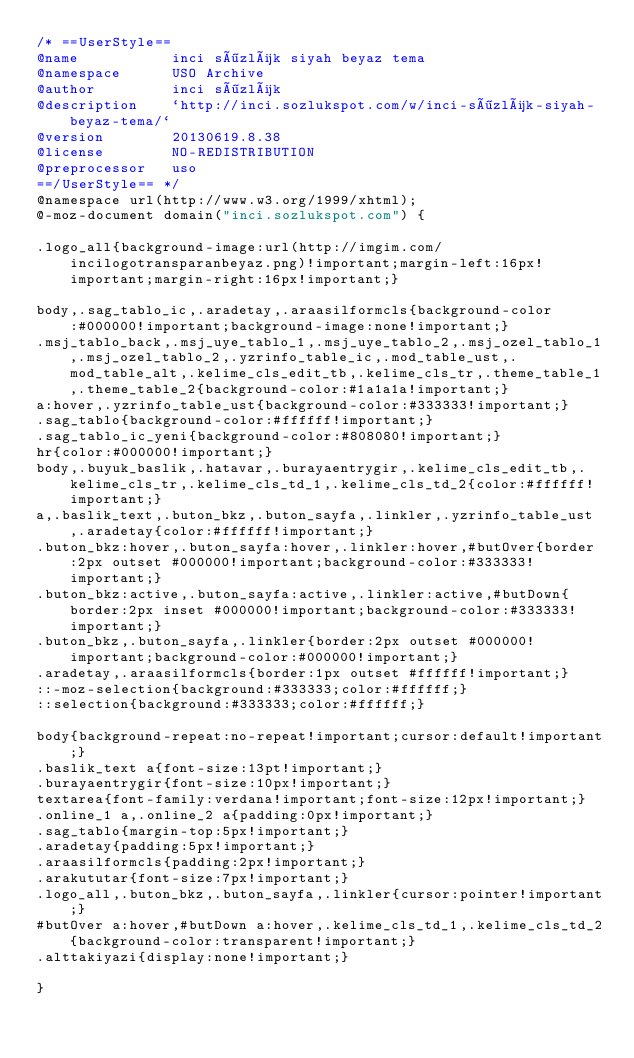<code> <loc_0><loc_0><loc_500><loc_500><_CSS_>/* ==UserStyle==
@name           inci sözlük siyah beyaz tema
@namespace      USO Archive
@author         inci sözlük
@description    `http://inci.sozlukspot.com/w/inci-sözlük-siyah-beyaz-tema/`
@version        20130619.8.38
@license        NO-REDISTRIBUTION
@preprocessor   uso
==/UserStyle== */
@namespace url(http://www.w3.org/1999/xhtml);
@-moz-document domain("inci.sozlukspot.com") {

.logo_all{background-image:url(http://imgim.com/incilogotransparanbeyaz.png)!important;margin-left:16px!important;margin-right:16px!important;}

body,.sag_tablo_ic,.aradetay,.araasilformcls{background-color:#000000!important;background-image:none!important;}
.msj_tablo_back,.msj_uye_tablo_1,.msj_uye_tablo_2,.msj_ozel_tablo_1,.msj_ozel_tablo_2,.yzrinfo_table_ic,.mod_table_ust,.mod_table_alt,.kelime_cls_edit_tb,.kelime_cls_tr,.theme_table_1,.theme_table_2{background-color:#1a1a1a!important;}
a:hover,.yzrinfo_table_ust{background-color:#333333!important;}
.sag_tablo{background-color:#ffffff!important;}
.sag_tablo_ic_yeni{background-color:#808080!important;}
hr{color:#000000!important;}
body,.buyuk_baslik,.hatavar,.burayaentrygir,.kelime_cls_edit_tb,.kelime_cls_tr,.kelime_cls_td_1,.kelime_cls_td_2{color:#ffffff!important;}
a,.baslik_text,.buton_bkz,.buton_sayfa,.linkler,.yzrinfo_table_ust,.aradetay{color:#ffffff!important;}
.buton_bkz:hover,.buton_sayfa:hover,.linkler:hover,#butOver{border:2px outset #000000!important;background-color:#333333!important;}
.buton_bkz:active,.buton_sayfa:active,.linkler:active,#butDown{border:2px inset #000000!important;background-color:#333333!important;}
.buton_bkz,.buton_sayfa,.linkler{border:2px outset #000000!important;background-color:#000000!important;}
.aradetay,.araasilformcls{border:1px outset #ffffff!important;}
::-moz-selection{background:#333333;color:#ffffff;}
::selection{background:#333333;color:#ffffff;}

body{background-repeat:no-repeat!important;cursor:default!important;}
.baslik_text a{font-size:13pt!important;}
.burayaentrygir{font-size:10px!important;}
textarea{font-family:verdana!important;font-size:12px!important;}
.online_1 a,.online_2 a{padding:0px!important;}
.sag_tablo{margin-top:5px!important;}
.aradetay{padding:5px!important;}
.araasilformcls{padding:2px!important;}
.arakututar{font-size:7px!important;}
.logo_all,.buton_bkz,.buton_sayfa,.linkler{cursor:pointer!important;}
#butOver a:hover,#butDown a:hover,.kelime_cls_td_1,.kelime_cls_td_2{background-color:transparent!important;}
.alttakiyazi{display:none!important;}

}</code> 